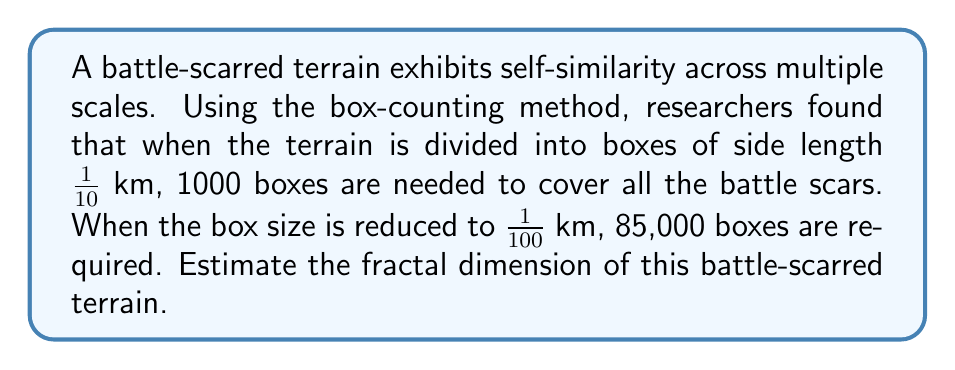Can you solve this math problem? To estimate the fractal dimension using the box-counting method, we can use the following steps:

1. Let $D$ be the fractal dimension we want to estimate.

2. The box-counting method is based on the relationship:

   $$N(r) \approx C \cdot r^{-D}$$

   where $N(r)$ is the number of boxes of side length $r$ needed to cover the fractal, $C$ is a constant, and $D$ is the fractal dimension.

3. Taking the logarithm of both sides:

   $$\log N(r) \approx \log C - D \log r$$

4. We have two data points:
   - When $r_1 = \frac{1}{10}$ km, $N(r_1) = 1000$
   - When $r_2 = \frac{1}{100}$ km, $N(r_2) = 85000$

5. We can estimate $D$ using:

   $$D \approx -\frac{\log N(r_2) - \log N(r_1)}{\log r_2 - \log r_1}$$

6. Substituting the values:

   $$D \approx -\frac{\log 85000 - \log 1000}{\log (\frac{1}{100}) - \log (\frac{1}{10})}$$

7. Simplifying:

   $$D \approx -\frac{\log 85 - 0}{\log 0.01 - \log 0.1} = \frac{\log 85}{\log 10} \approx 1.93$$

Therefore, the estimated fractal dimension of the battle-scarred terrain is approximately 1.93.
Answer: 1.93 